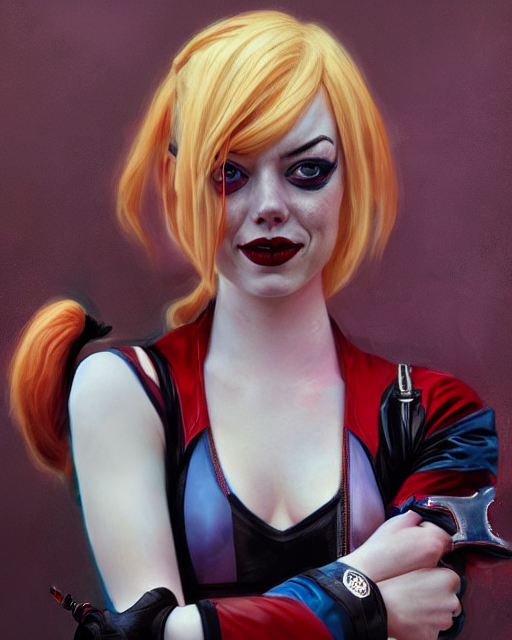Which elements of the image suggest a particular style or theme? The subject's costume, with its red and blue color scheme, along with her hairstyle and makeup, suggests a theme inspired by comic books or graphic novels. Her confident pose and glance, as well as the choice of red and black clothing with a symbol on the sleeve, imply a character of some significance in a narrative, likely possessing a bold and flamboyant personality. These elements collectively point to a stylistic theme commonly associated with superhero or supervillain personas. 